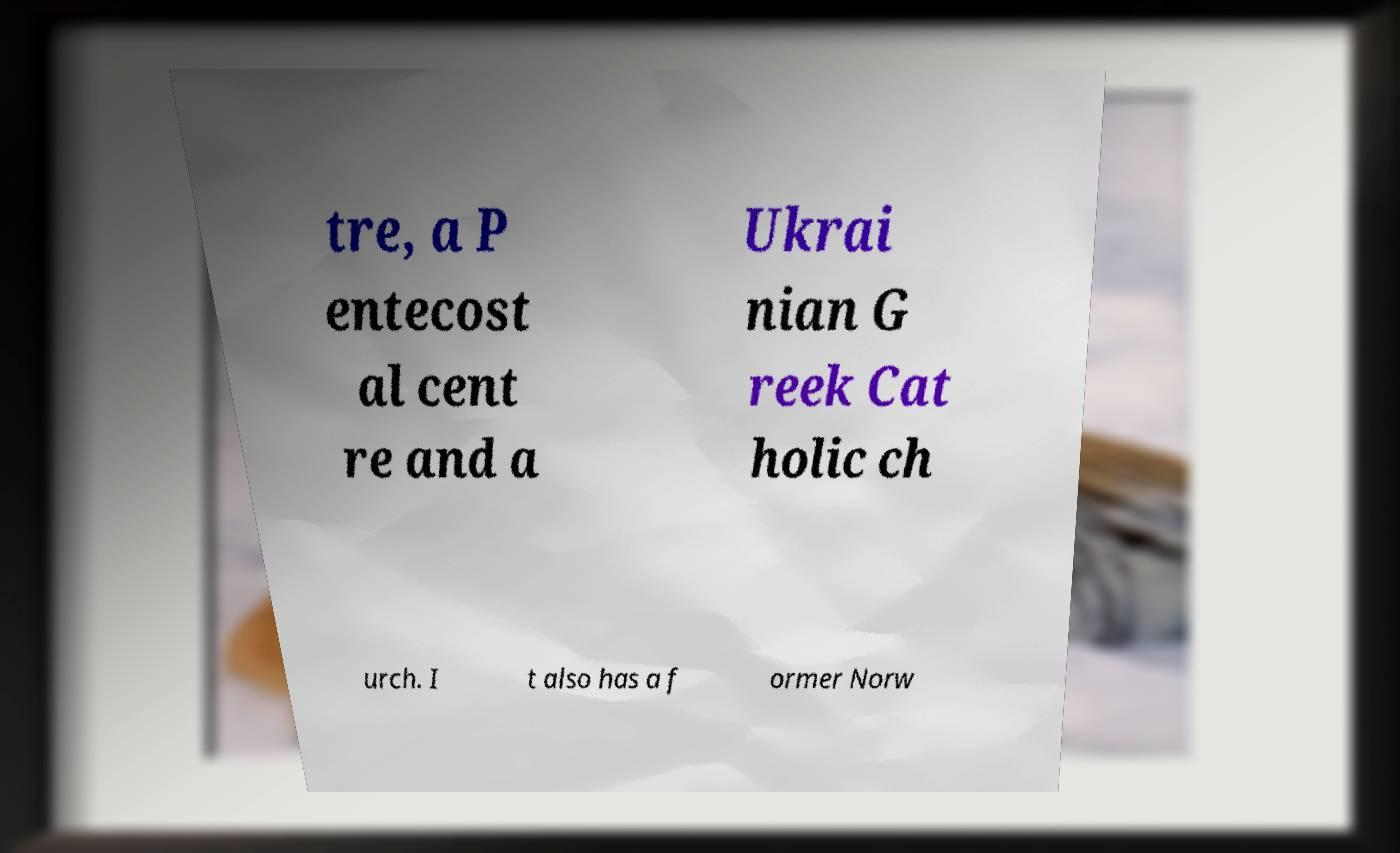I need the written content from this picture converted into text. Can you do that? tre, a P entecost al cent re and a Ukrai nian G reek Cat holic ch urch. I t also has a f ormer Norw 